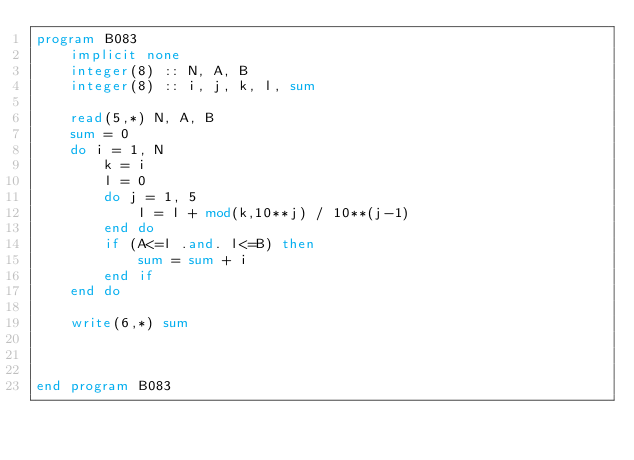<code> <loc_0><loc_0><loc_500><loc_500><_FORTRAN_>program B083
    implicit none
    integer(8) :: N, A, B
    integer(8) :: i, j, k, l, sum

    read(5,*) N, A, B
    sum = 0
    do i = 1, N
        k = i
        l = 0
        do j = 1, 5
            l = l + mod(k,10**j) / 10**(j-1)
        end do
        if (A<=l .and. l<=B) then
            sum = sum + i
        end if
    end do

    write(6,*) sum



end program B083</code> 